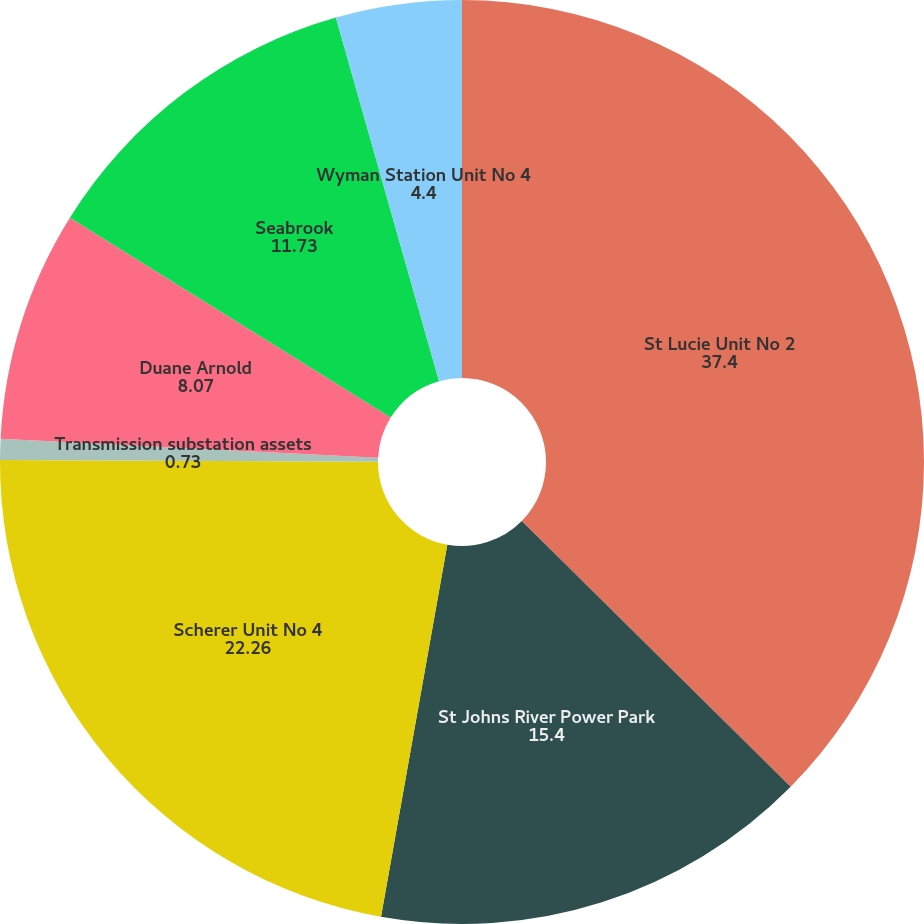Convert chart. <chart><loc_0><loc_0><loc_500><loc_500><pie_chart><fcel>St Lucie Unit No 2<fcel>St Johns River Power Park<fcel>Scherer Unit No 4<fcel>Transmission substation assets<fcel>Duane Arnold<fcel>Seabrook<fcel>Wyman Station Unit No 4<nl><fcel>37.4%<fcel>15.4%<fcel>22.26%<fcel>0.73%<fcel>8.07%<fcel>11.73%<fcel>4.4%<nl></chart> 